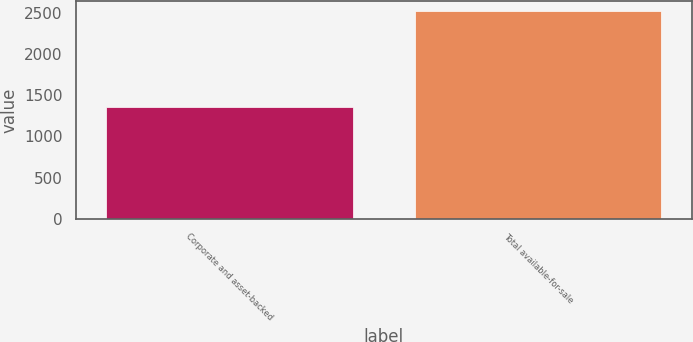Convert chart to OTSL. <chart><loc_0><loc_0><loc_500><loc_500><bar_chart><fcel>Corporate and asset-backed<fcel>Total available-for-sale<nl><fcel>1353<fcel>2515<nl></chart> 